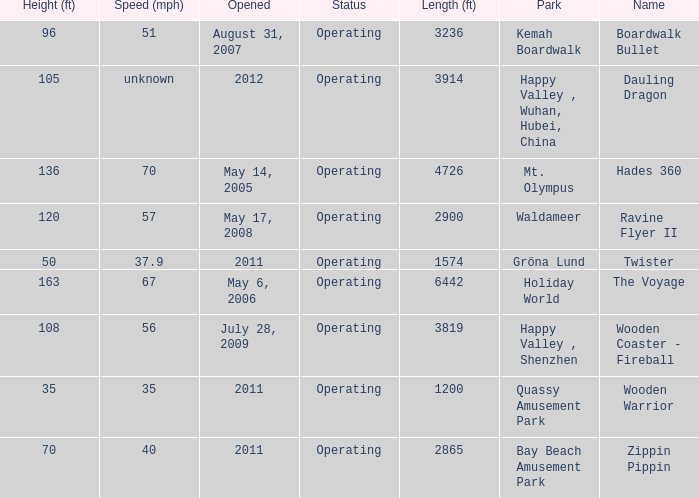How long is the rollar coaster on Kemah Boardwalk 3236.0. 